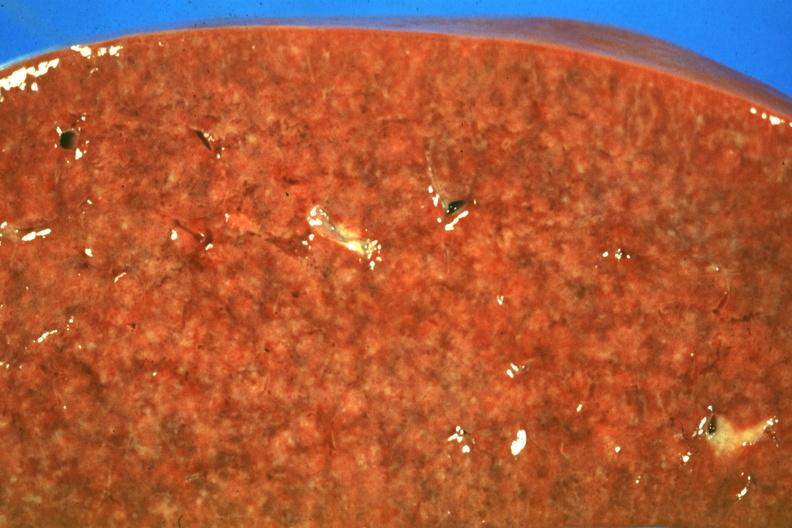s carcinoma superficial spreading present?
Answer the question using a single word or phrase. No 